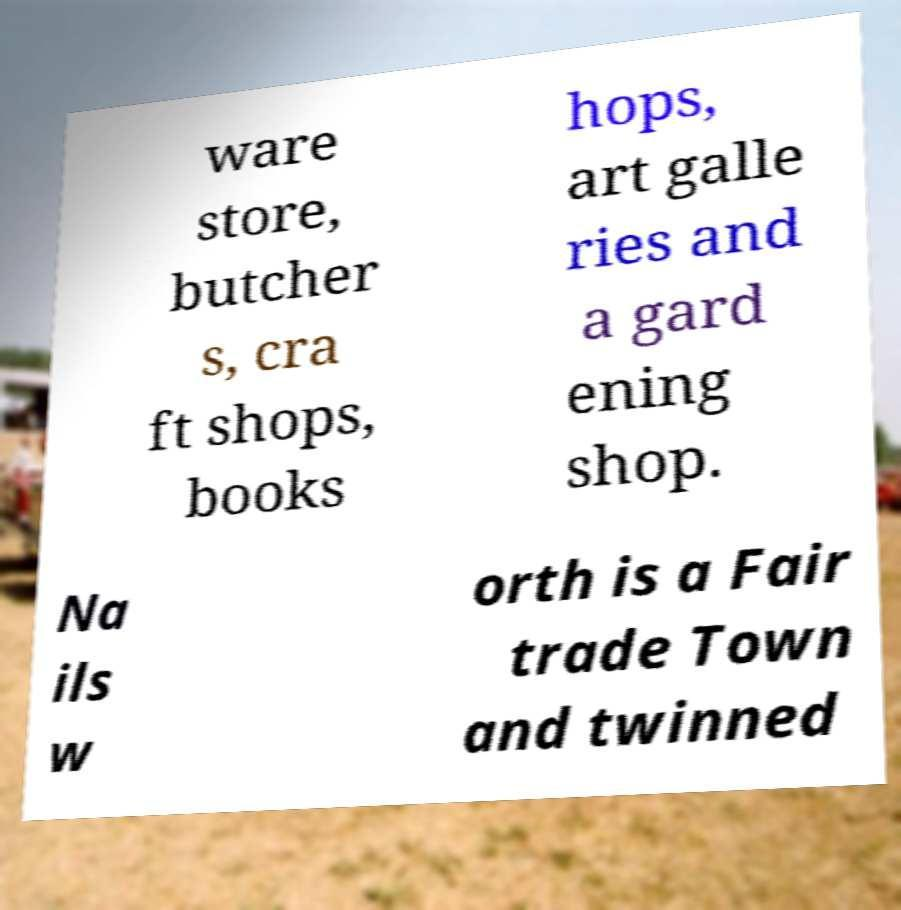Please identify and transcribe the text found in this image. ware store, butcher s, cra ft shops, books hops, art galle ries and a gard ening shop. Na ils w orth is a Fair trade Town and twinned 